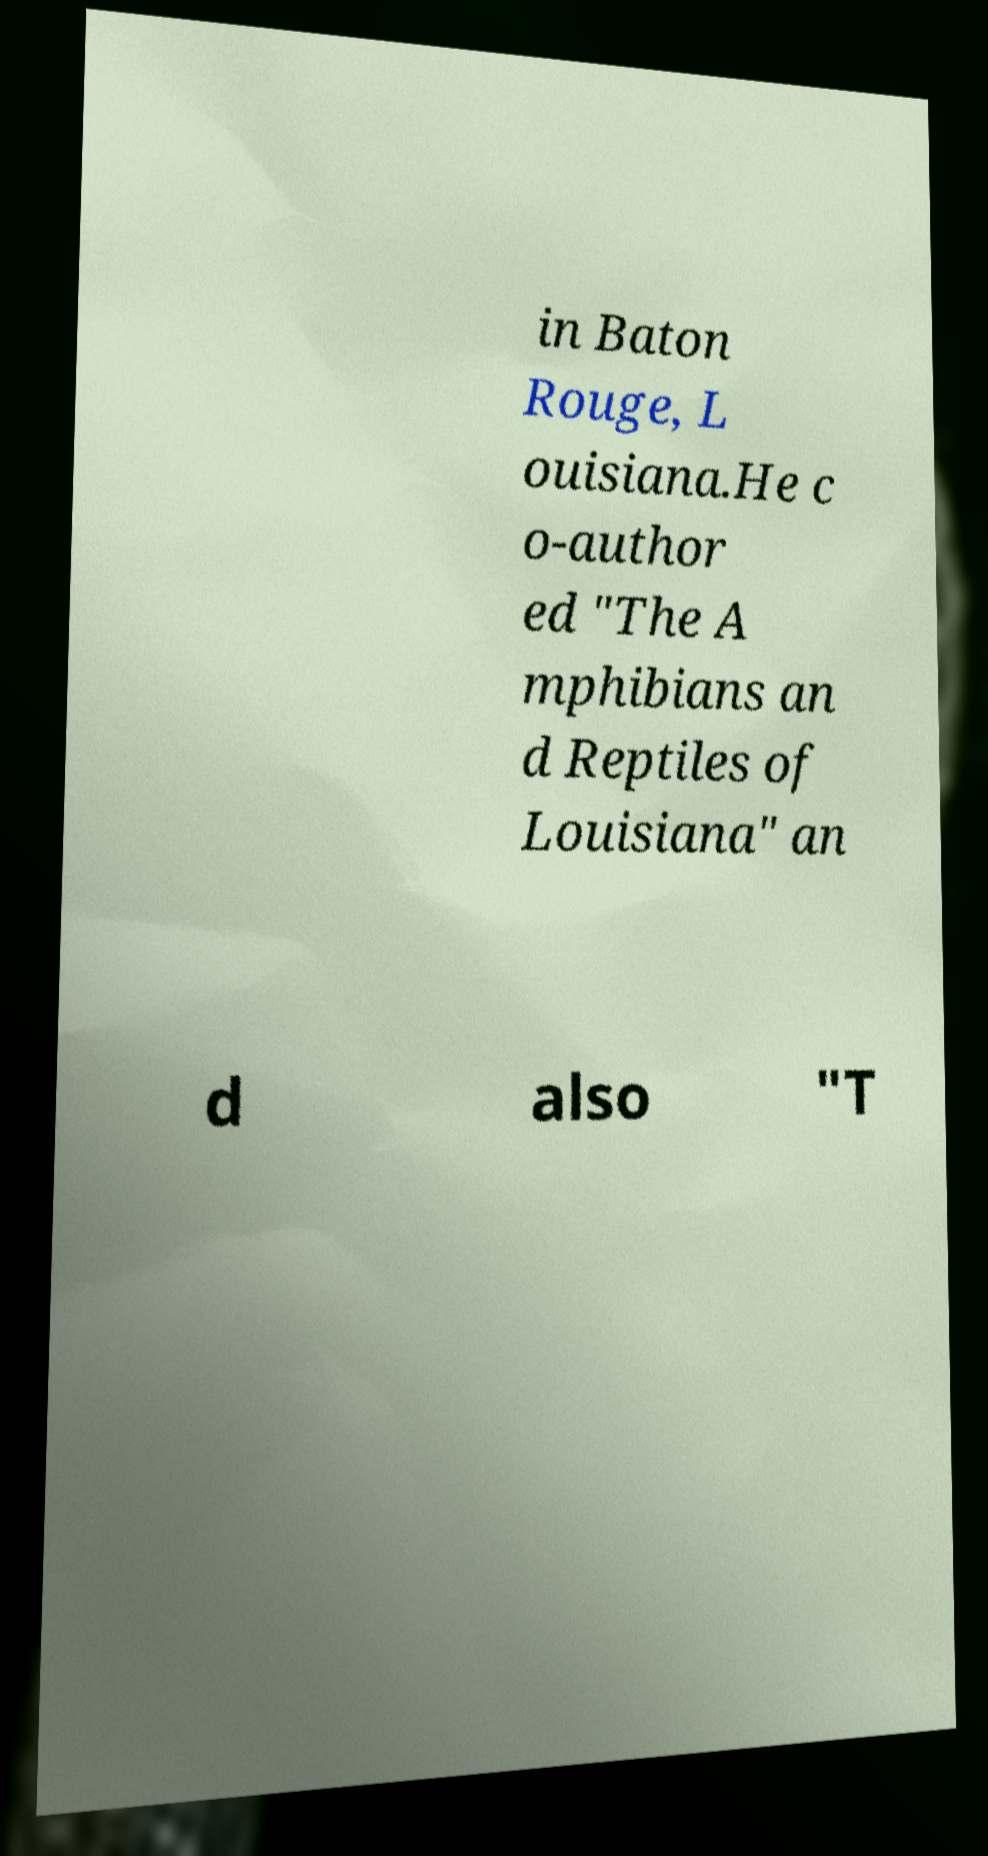Please identify and transcribe the text found in this image. in Baton Rouge, L ouisiana.He c o-author ed "The A mphibians an d Reptiles of Louisiana" an d also "T 